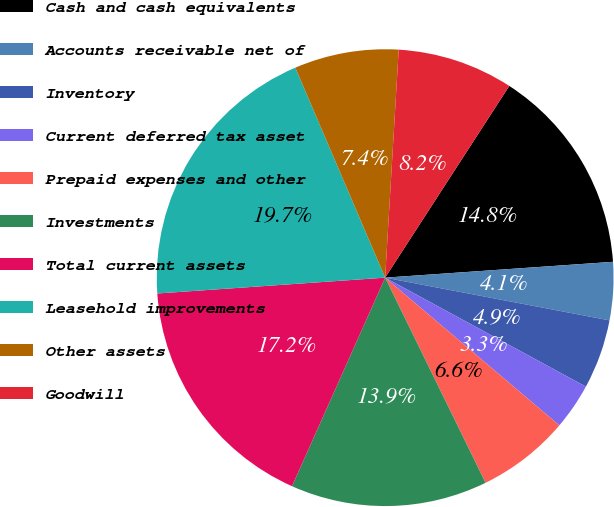Convert chart to OTSL. <chart><loc_0><loc_0><loc_500><loc_500><pie_chart><fcel>Cash and cash equivalents<fcel>Accounts receivable net of<fcel>Inventory<fcel>Current deferred tax asset<fcel>Prepaid expenses and other<fcel>Investments<fcel>Total current assets<fcel>Leasehold improvements<fcel>Other assets<fcel>Goodwill<nl><fcel>14.75%<fcel>4.1%<fcel>4.92%<fcel>3.28%<fcel>6.56%<fcel>13.93%<fcel>17.21%<fcel>19.67%<fcel>7.38%<fcel>8.2%<nl></chart> 